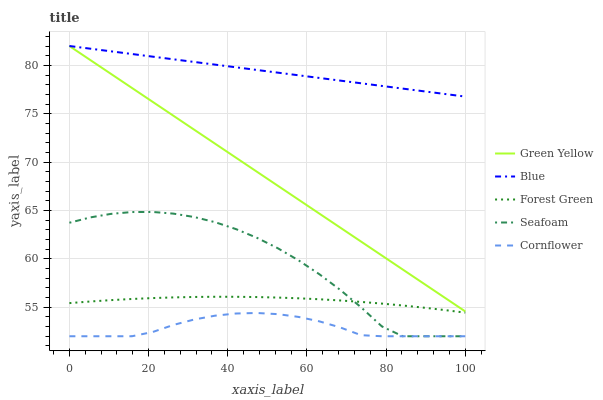Does Cornflower have the minimum area under the curve?
Answer yes or no. Yes. Does Blue have the maximum area under the curve?
Answer yes or no. Yes. Does Forest Green have the minimum area under the curve?
Answer yes or no. No. Does Forest Green have the maximum area under the curve?
Answer yes or no. No. Is Green Yellow the smoothest?
Answer yes or no. Yes. Is Seafoam the roughest?
Answer yes or no. Yes. Is Cornflower the smoothest?
Answer yes or no. No. Is Cornflower the roughest?
Answer yes or no. No. Does Cornflower have the lowest value?
Answer yes or no. Yes. Does Forest Green have the lowest value?
Answer yes or no. No. Does Green Yellow have the highest value?
Answer yes or no. Yes. Does Forest Green have the highest value?
Answer yes or no. No. Is Cornflower less than Forest Green?
Answer yes or no. Yes. Is Blue greater than Seafoam?
Answer yes or no. Yes. Does Seafoam intersect Cornflower?
Answer yes or no. Yes. Is Seafoam less than Cornflower?
Answer yes or no. No. Is Seafoam greater than Cornflower?
Answer yes or no. No. Does Cornflower intersect Forest Green?
Answer yes or no. No. 